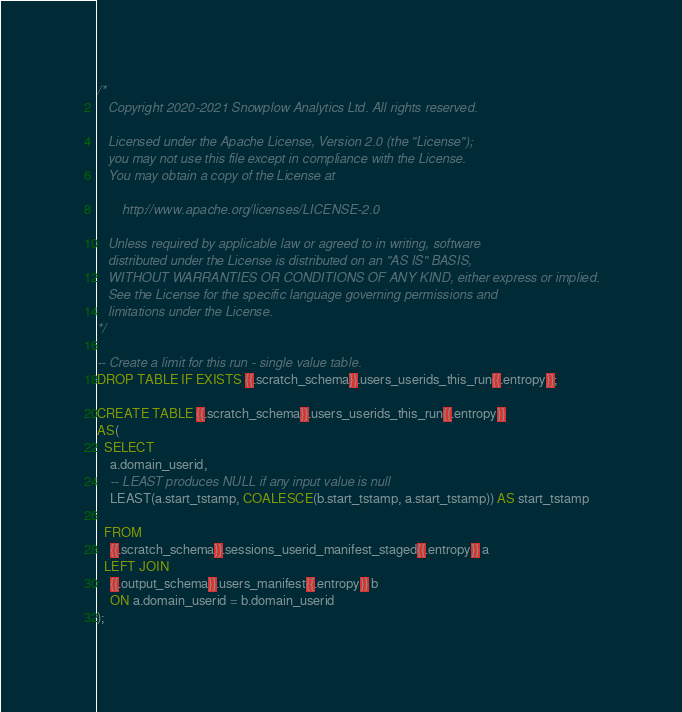<code> <loc_0><loc_0><loc_500><loc_500><_SQL_>/*
   Copyright 2020-2021 Snowplow Analytics Ltd. All rights reserved.

   Licensed under the Apache License, Version 2.0 (the "License");
   you may not use this file except in compliance with the License.
   You may obtain a copy of the License at

       http://www.apache.org/licenses/LICENSE-2.0

   Unless required by applicable law or agreed to in writing, software
   distributed under the License is distributed on an "AS IS" BASIS,
   WITHOUT WARRANTIES OR CONDITIONS OF ANY KIND, either express or implied.
   See the License for the specific language governing permissions and
   limitations under the License.
*/

-- Create a limit for this run - single value table.
DROP TABLE IF EXISTS {{.scratch_schema}}.users_userids_this_run{{.entropy}};

CREATE TABLE {{.scratch_schema}}.users_userids_this_run{{.entropy}}
AS(
  SELECT
    a.domain_userid,
    -- LEAST produces NULL if any input value is null
    LEAST(a.start_tstamp, COALESCE(b.start_tstamp, a.start_tstamp)) AS start_tstamp

  FROM
    {{.scratch_schema}}.sessions_userid_manifest_staged{{.entropy}} a
  LEFT JOIN
    {{.output_schema}}.users_manifest{{.entropy}} b
    ON a.domain_userid = b.domain_userid
);
</code> 